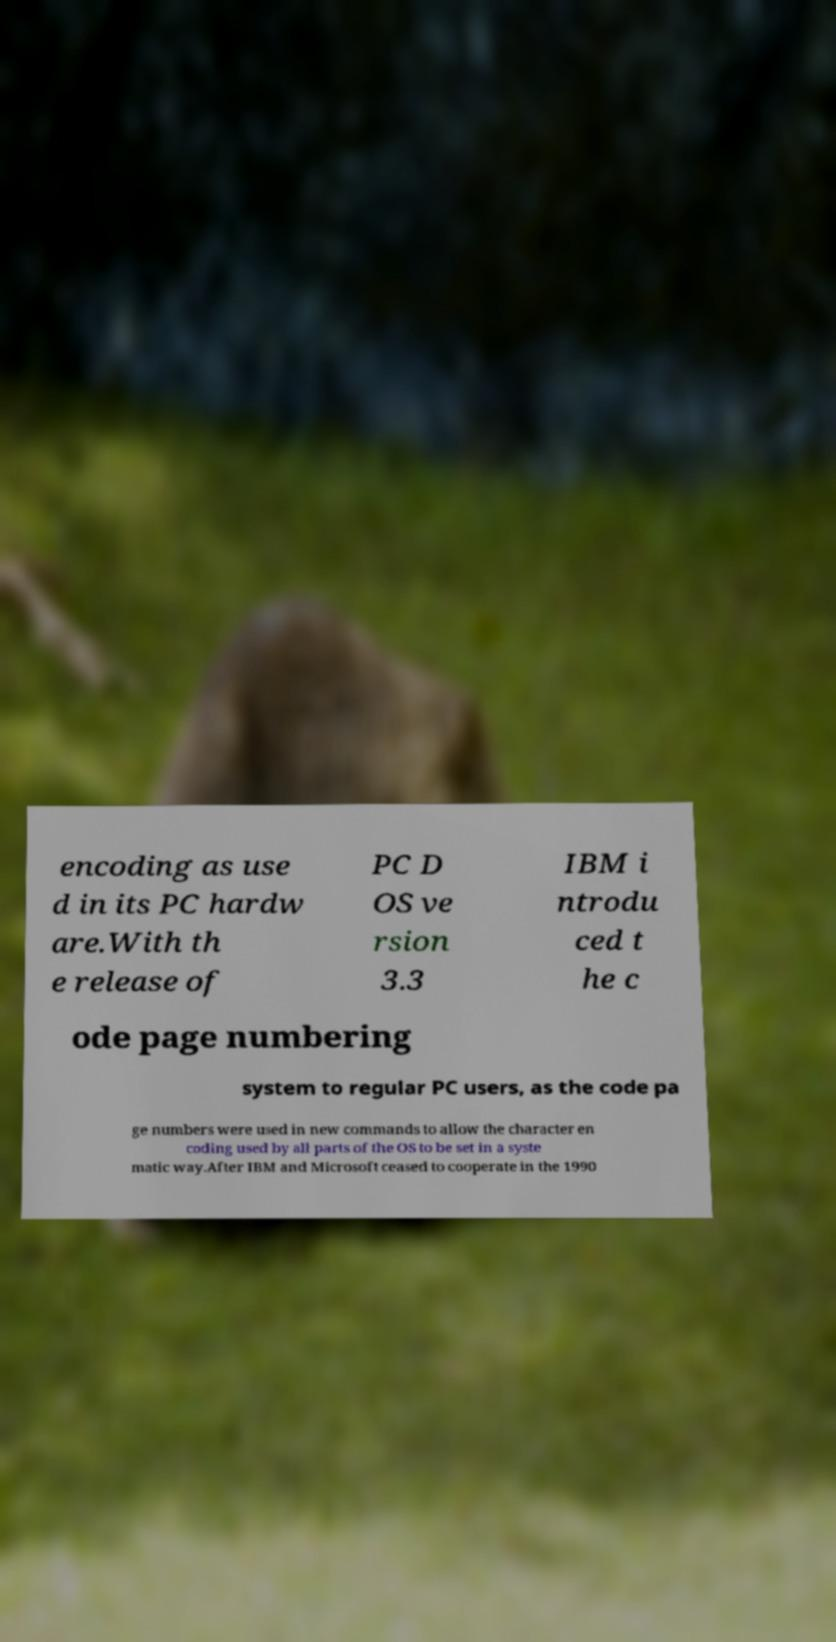What messages or text are displayed in this image? I need them in a readable, typed format. encoding as use d in its PC hardw are.With th e release of PC D OS ve rsion 3.3 IBM i ntrodu ced t he c ode page numbering system to regular PC users, as the code pa ge numbers were used in new commands to allow the character en coding used by all parts of the OS to be set in a syste matic way.After IBM and Microsoft ceased to cooperate in the 1990 